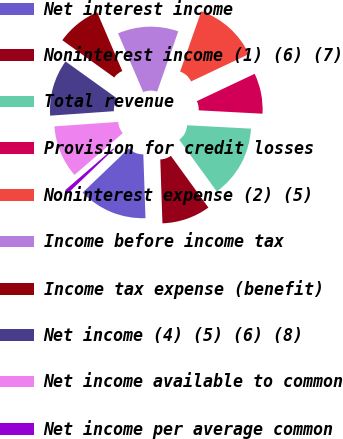Convert chart to OTSL. <chart><loc_0><loc_0><loc_500><loc_500><pie_chart><fcel>Net interest income<fcel>Noninterest income (1) (6) (7)<fcel>Total revenue<fcel>Provision for credit losses<fcel>Noninterest expense (2) (5)<fcel>Income before income tax<fcel>Income tax expense (benefit)<fcel>Net income (4) (5) (6) (8)<fcel>Net income available to common<fcel>Net income per average common<nl><fcel>13.39%<fcel>9.45%<fcel>14.17%<fcel>7.87%<fcel>12.6%<fcel>11.81%<fcel>8.66%<fcel>11.02%<fcel>10.24%<fcel>0.79%<nl></chart> 